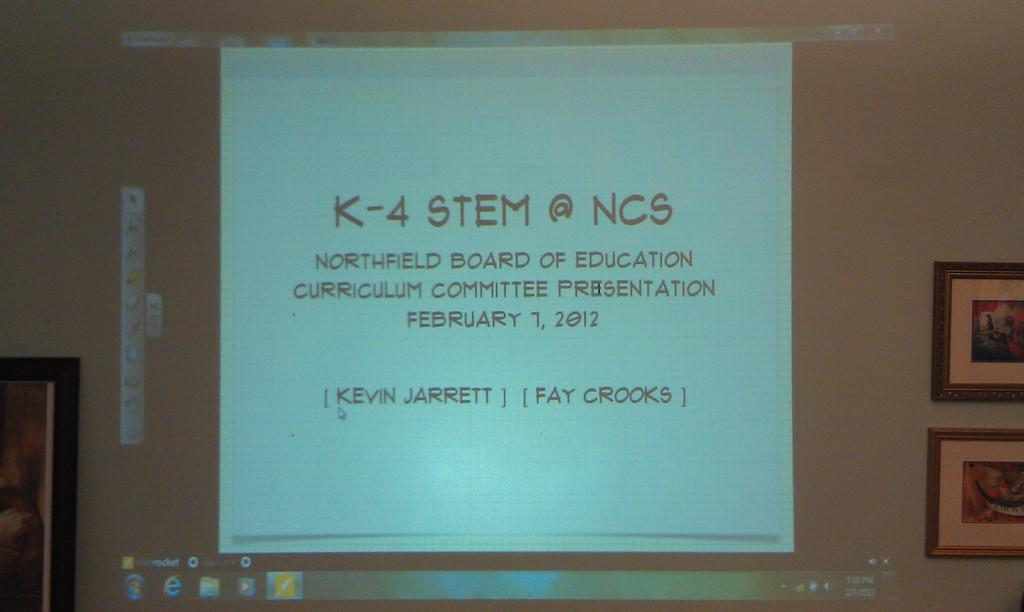What is the main object in the image? There is a display screen in the image. What can be seen on the display screen? Text is visible on the display screen. Are there any decorations on the wall in the image? Yes, there are wall hangings attached to the wall in the image. How many ladybugs are crawling on the display screen in the image? There are no ladybugs present on the display screen or in the image. 